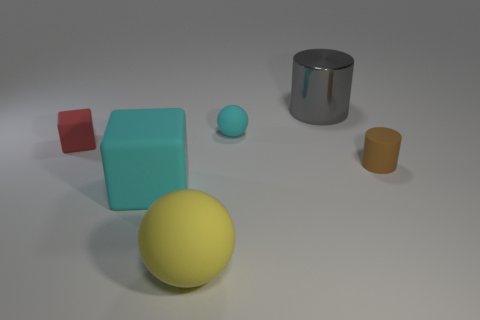What materials do the objects in the image appear to be made from? The objects in the image appear to be digitally rendered and simulate various materials. The large yellow sphere and small blue matte sphere seem to mimic a plastic material, while the large cube exhibits a matte finish, perhaps resembling painted wood or matte plastic. The small red cube looks glossy, potentially indicative of polished plastic or glass. Lastly, the gray cylinder and the small yellow cylinder have a reflective surface that suggests a metallic composition, resembling brushed steel and brushed bronze, respectively. 